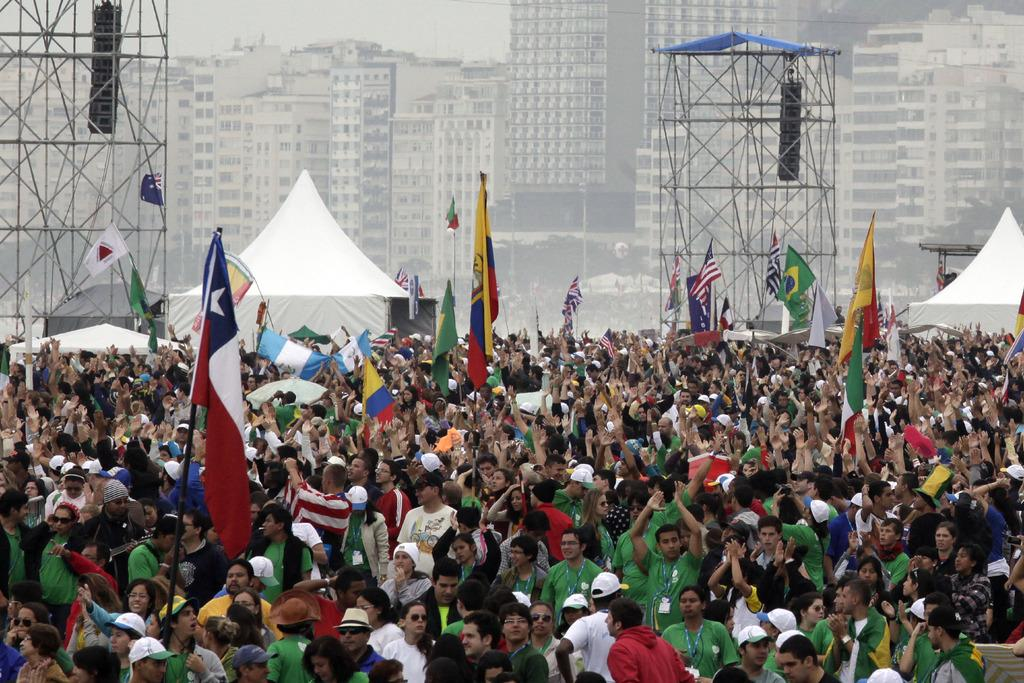What are the people at the bottom of the image doing? Some of the people are holding flag poles. What can be seen in the background of the image? There are poles, tents, trees, buildings, and the sky visible in the background of the image. How many different types of objects can be seen in the background? There are five different types of objects in the background: poles, tents, trees, buildings, and the sky. What song is being sung by the people in the image? There is no indication in the image that the people are singing a song. What type of peace offering is being made by the people in the image? There is no peace offering being made in the image; the people are holding flag poles. 